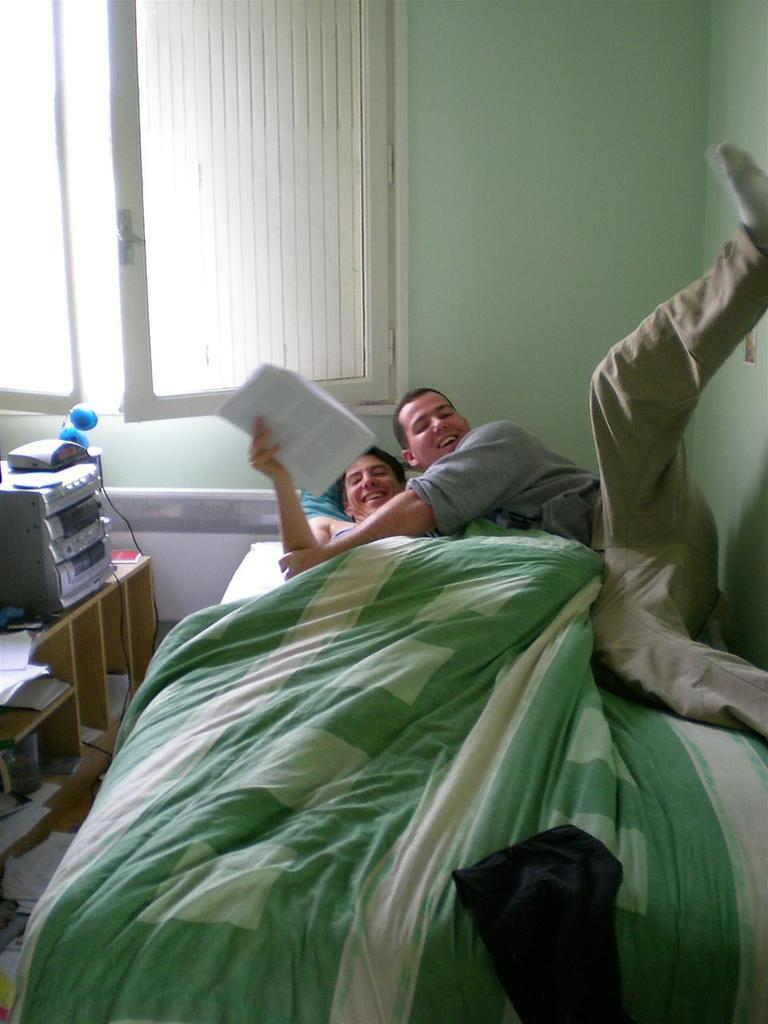How many people are in the image? There are two men in the image. What are the men doing in the image? The men are laying on a bed. What can be seen in the background of the image? There is a window in the image. What is on the table in front of the window? There is a music player on the table. Can you see any sugar on the bed in the image? There is no sugar visible on the bed in the image. What type of ocean can be seen through the window in the image? There is no ocean visible through the window in the image; it is a room with a window. 